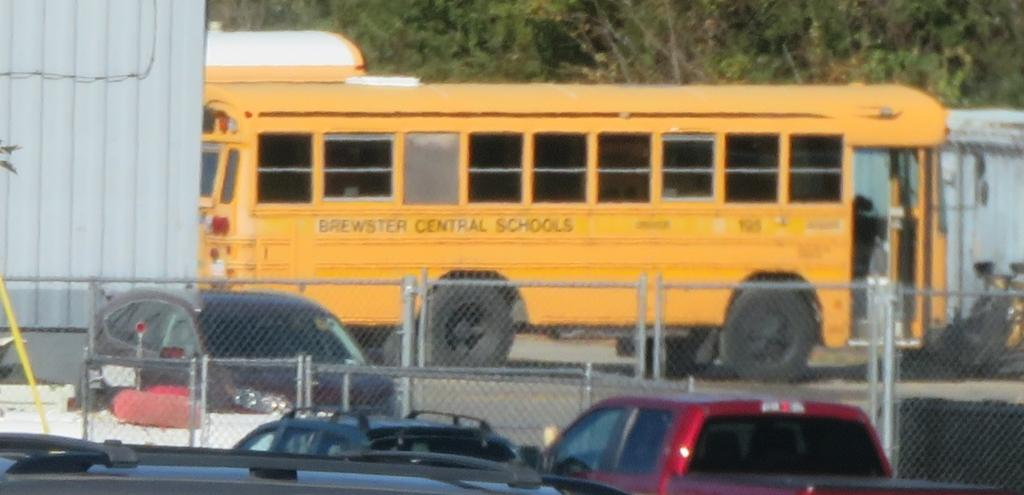Provide a one-sentence caption for the provided image. A Brewster Central School School Bus sitting around a bunch of cars. 